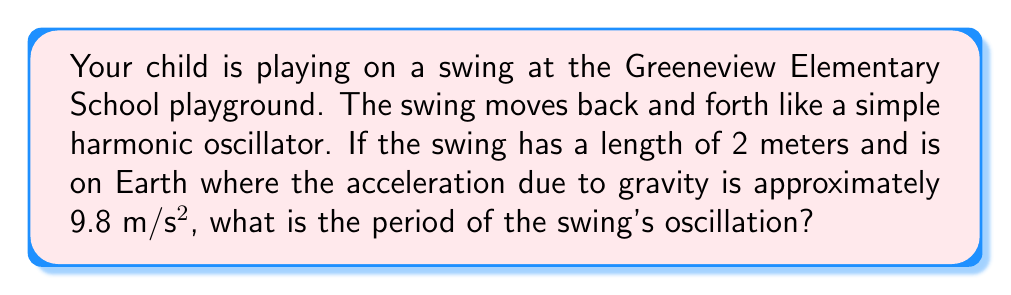Provide a solution to this math problem. To solve this problem, we'll use the formula for the period of a simple pendulum, which is a good approximation for a swing:

$$T = 2\pi\sqrt{\frac{L}{g}}$$

Where:
$T$ = period of oscillation
$L$ = length of the pendulum (swing)
$g$ = acceleration due to gravity

Given:
$L = 2$ meters
$g = 9.8$ m/s²

Let's substitute these values into the equation:

$$T = 2\pi\sqrt{\frac{2}{9.8}}$$

Simplify inside the square root:
$$T = 2\pi\sqrt{0.2040816...}$$

Calculate the square root:
$$T = 2\pi(0.4516...)$$

Multiply by $2\pi$:
$$T = 2.837...$$

Rounding to two decimal places:
$$T \approx 2.84 \text{ seconds}$$
Answer: $2.84 \text{ seconds}$ 